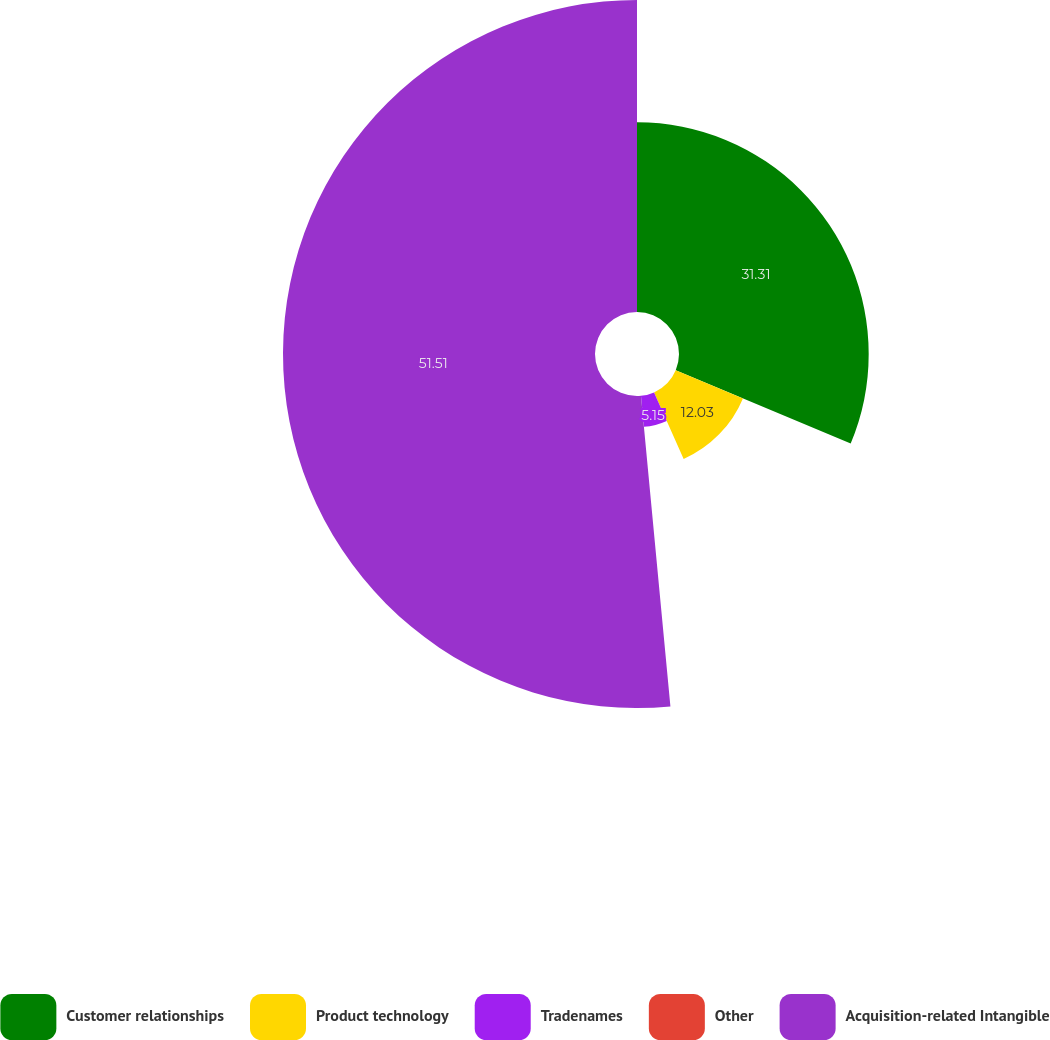Convert chart. <chart><loc_0><loc_0><loc_500><loc_500><pie_chart><fcel>Customer relationships<fcel>Product technology<fcel>Tradenames<fcel>Other<fcel>Acquisition-related Intangible<nl><fcel>31.31%<fcel>12.03%<fcel>5.15%<fcel>0.0%<fcel>51.5%<nl></chart> 